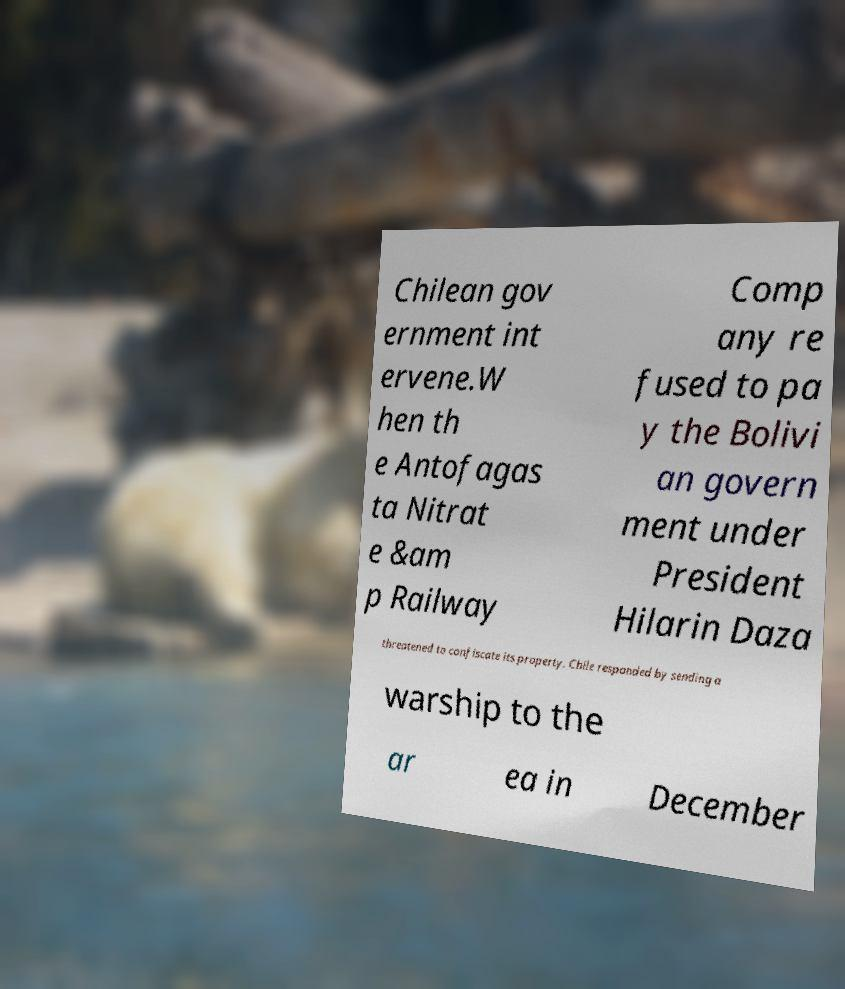Could you assist in decoding the text presented in this image and type it out clearly? Chilean gov ernment int ervene.W hen th e Antofagas ta Nitrat e &am p Railway Comp any re fused to pa y the Bolivi an govern ment under President Hilarin Daza threatened to confiscate its property. Chile responded by sending a warship to the ar ea in December 